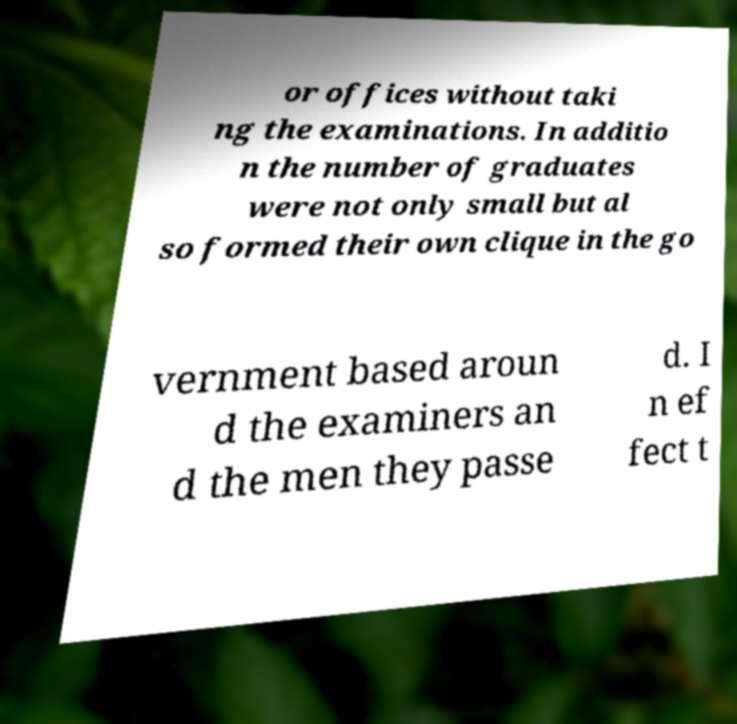Could you assist in decoding the text presented in this image and type it out clearly? or offices without taki ng the examinations. In additio n the number of graduates were not only small but al so formed their own clique in the go vernment based aroun d the examiners an d the men they passe d. I n ef fect t 